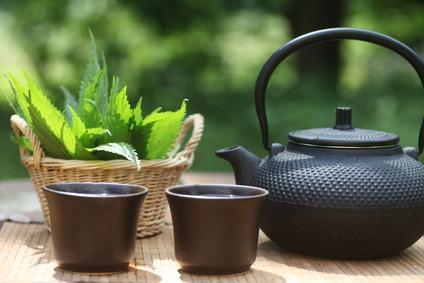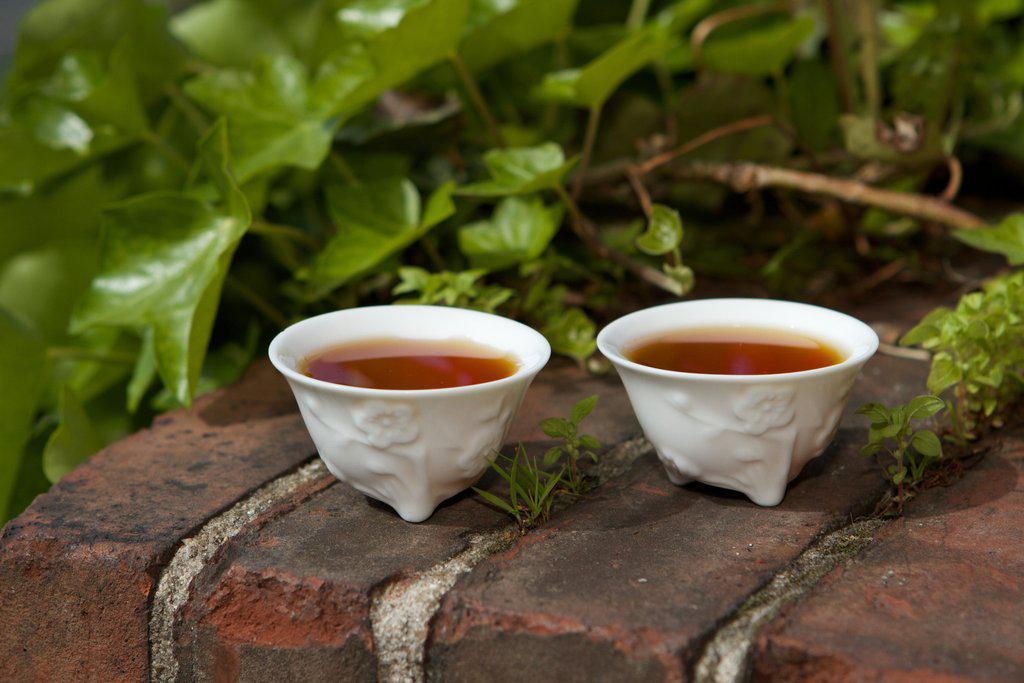The first image is the image on the left, the second image is the image on the right. Evaluate the accuracy of this statement regarding the images: "There are no less than two coffee mugs with handles". Is it true? Answer yes or no. No. The first image is the image on the left, the second image is the image on the right. Examine the images to the left and right. Is the description "Brown liquid sits in a single mug in the cup on the left." accurate? Answer yes or no. No. 